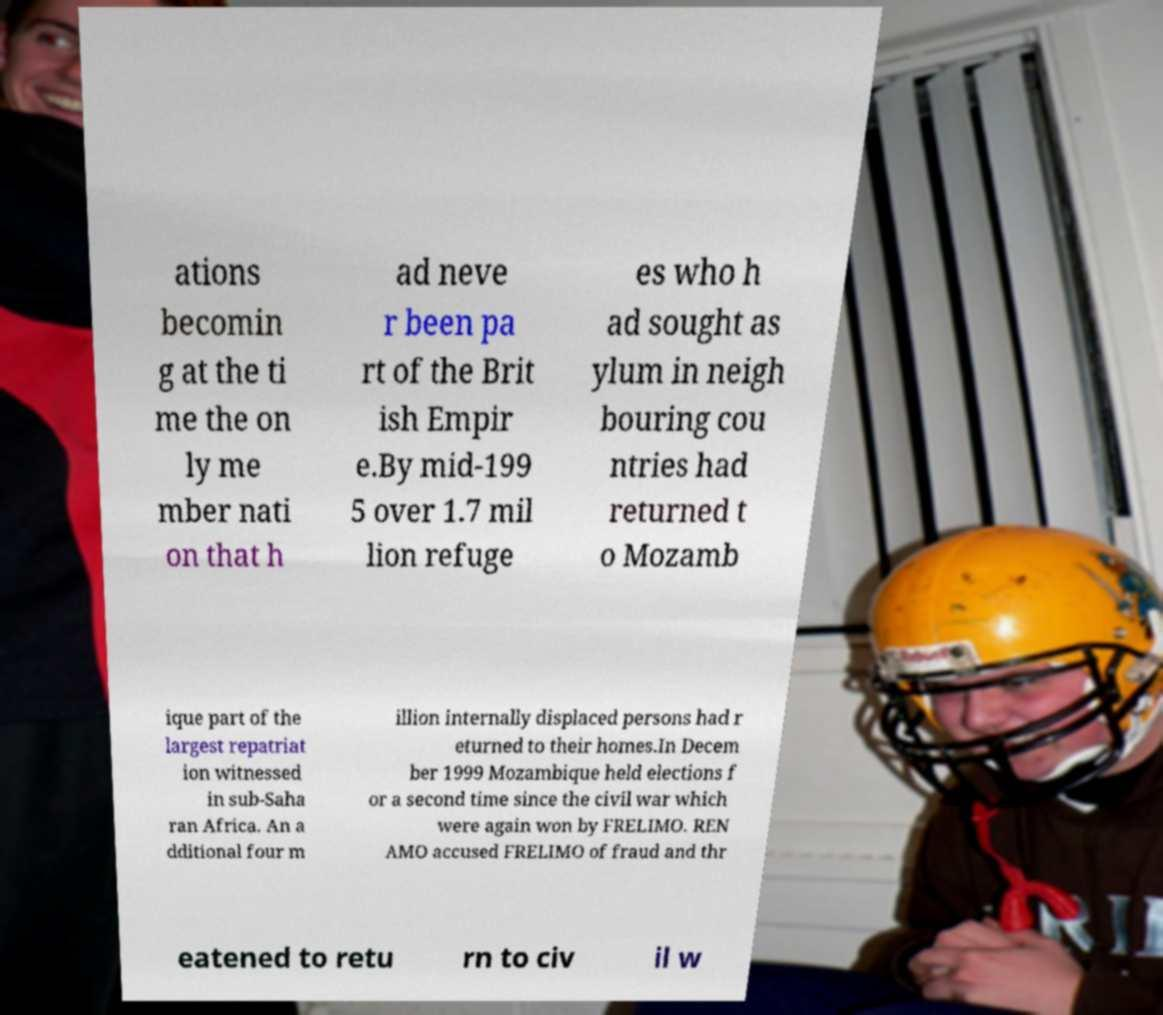Could you assist in decoding the text presented in this image and type it out clearly? ations becomin g at the ti me the on ly me mber nati on that h ad neve r been pa rt of the Brit ish Empir e.By mid-199 5 over 1.7 mil lion refuge es who h ad sought as ylum in neigh bouring cou ntries had returned t o Mozamb ique part of the largest repatriat ion witnessed in sub-Saha ran Africa. An a dditional four m illion internally displaced persons had r eturned to their homes.In Decem ber 1999 Mozambique held elections f or a second time since the civil war which were again won by FRELIMO. REN AMO accused FRELIMO of fraud and thr eatened to retu rn to civ il w 